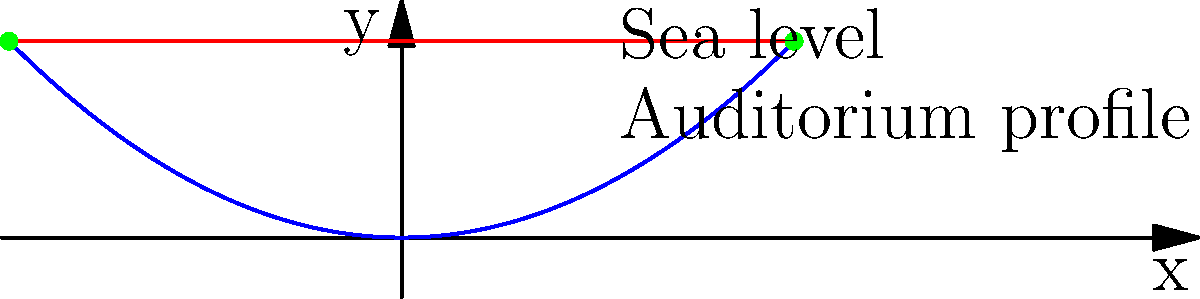The Alfredo Kraus Auditorium's unique architectural design features a curved facade facing the sea. The profile of the auditorium can be modeled by the function $f(x) = 0.05x^2$, where $x$ is the horizontal distance from the center in meters and $f(x)$ is the height in meters. The sea level is represented by the line $y = 5$. Calculate the total width of the auditorium at sea level. To find the width of the auditorium at sea level, we need to:

1) Find the points of intersection between the auditorium profile and the sea level.
2) Calculate the distance between these points.

Step 1: Find the points of intersection
We need to solve the equation:
$$ 0.05x^2 = 5 $$

Rearranging:
$$ x^2 = 100 $$

Taking the square root:
$$ x = \pm 10 $$

So the points of intersection are (-10, 5) and (10, 5).

Step 2: Calculate the distance
The distance between these points is simply the difference of their x-coordinates:
$$ 10 - (-10) = 20 $$

Therefore, the total width of the auditorium at sea level is 20 meters.
Answer: 20 meters 